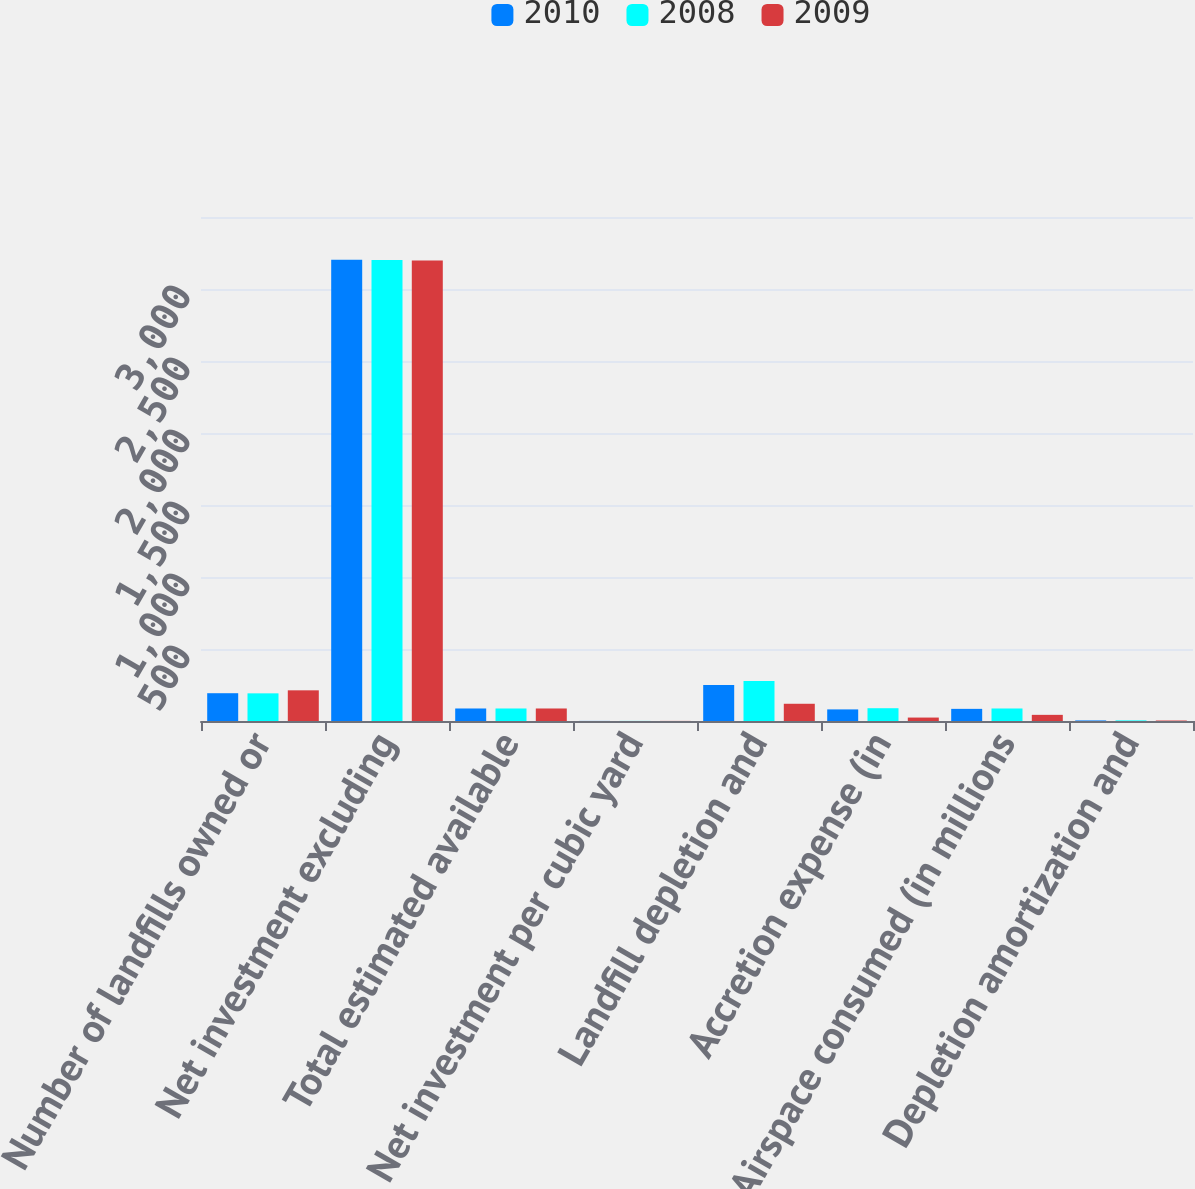Convert chart to OTSL. <chart><loc_0><loc_0><loc_500><loc_500><stacked_bar_chart><ecel><fcel>Number of landfills owned or<fcel>Net investment excluding<fcel>Total estimated available<fcel>Net investment per cubic yard<fcel>Landfill depletion and<fcel>Accretion expense (in<fcel>Airspace consumed (in millions<fcel>Depletion amortization and<nl><fcel>2010<fcel>193<fcel>3203.8<fcel>86.9<fcel>0.68<fcel>250.6<fcel>80.5<fcel>84.3<fcel>3.93<nl><fcel>2008<fcel>192<fcel>3200.6<fcel>86.9<fcel>0.69<fcel>278.5<fcel>88.8<fcel>86.9<fcel>4.23<nl><fcel>2009<fcel>213<fcel>3198.3<fcel>86.9<fcel>0.65<fcel>119.7<fcel>23.9<fcel>42.7<fcel>3.36<nl></chart> 